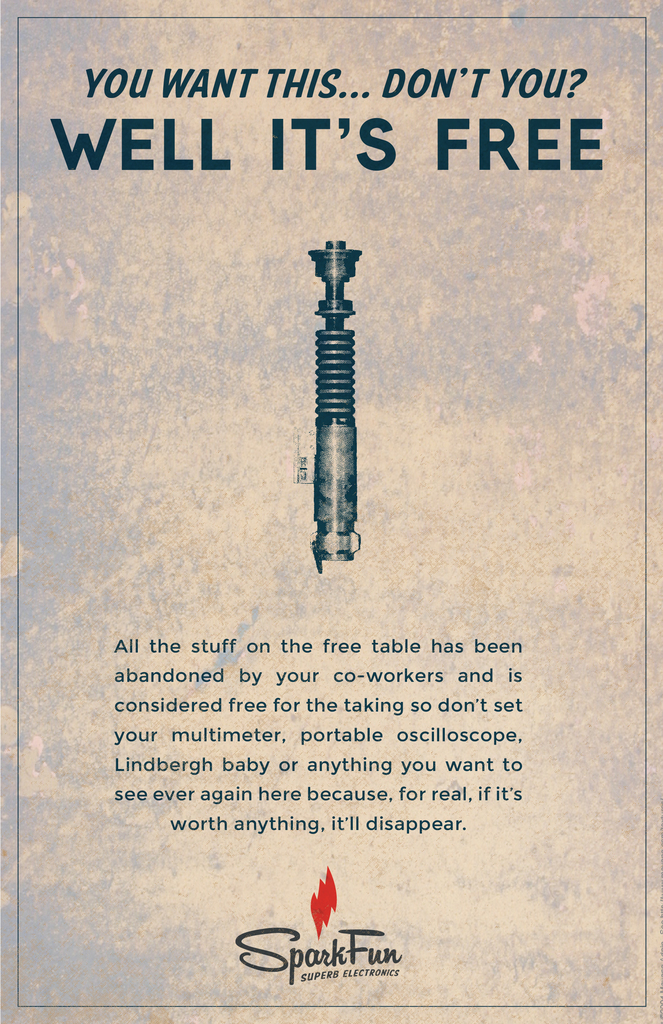What does the 'free' concept in this ad imply about the company culture at SparkFun? The 'free' concept in the ad implies a company culture that values open sharing and resourcefulness. It suggests SparkFun encourages a collaborative environment where items are recycled or reused rather than discarded, promoting sustainability and community engagement among employees. 